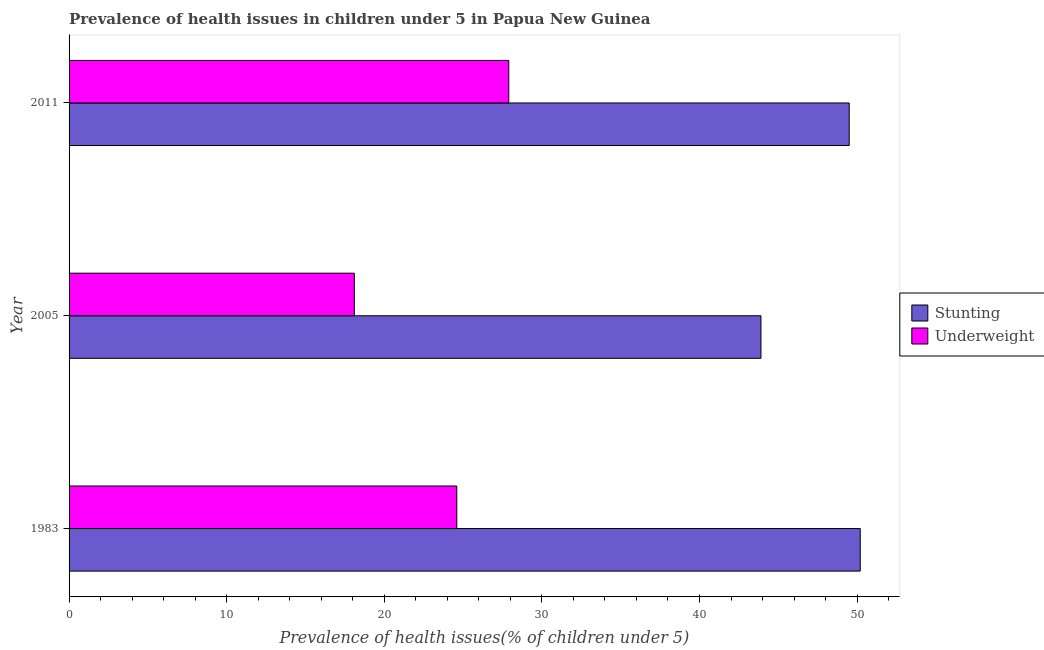Are the number of bars on each tick of the Y-axis equal?
Your answer should be very brief. Yes. How many bars are there on the 2nd tick from the bottom?
Keep it short and to the point. 2. What is the percentage of underweight children in 2011?
Your response must be concise. 27.9. Across all years, what is the maximum percentage of underweight children?
Offer a very short reply. 27.9. Across all years, what is the minimum percentage of underweight children?
Your response must be concise. 18.1. In which year was the percentage of stunted children maximum?
Provide a succinct answer. 1983. What is the total percentage of underweight children in the graph?
Ensure brevity in your answer.  70.6. What is the difference between the percentage of underweight children in 2011 and the percentage of stunted children in 1983?
Offer a very short reply. -22.3. What is the average percentage of stunted children per year?
Give a very brief answer. 47.87. In the year 2005, what is the difference between the percentage of stunted children and percentage of underweight children?
Offer a terse response. 25.8. In how many years, is the percentage of stunted children greater than 38 %?
Make the answer very short. 3. What is the ratio of the percentage of underweight children in 2005 to that in 2011?
Offer a terse response. 0.65. In how many years, is the percentage of stunted children greater than the average percentage of stunted children taken over all years?
Offer a very short reply. 2. Is the sum of the percentage of stunted children in 1983 and 2005 greater than the maximum percentage of underweight children across all years?
Offer a terse response. Yes. What does the 2nd bar from the top in 2011 represents?
Your answer should be compact. Stunting. What does the 2nd bar from the bottom in 2011 represents?
Offer a terse response. Underweight. Are all the bars in the graph horizontal?
Your answer should be compact. Yes. How are the legend labels stacked?
Offer a very short reply. Vertical. What is the title of the graph?
Ensure brevity in your answer.  Prevalence of health issues in children under 5 in Papua New Guinea. What is the label or title of the X-axis?
Your answer should be compact. Prevalence of health issues(% of children under 5). What is the Prevalence of health issues(% of children under 5) in Stunting in 1983?
Your answer should be very brief. 50.2. What is the Prevalence of health issues(% of children under 5) in Underweight in 1983?
Give a very brief answer. 24.6. What is the Prevalence of health issues(% of children under 5) in Stunting in 2005?
Offer a very short reply. 43.9. What is the Prevalence of health issues(% of children under 5) of Underweight in 2005?
Keep it short and to the point. 18.1. What is the Prevalence of health issues(% of children under 5) in Stunting in 2011?
Provide a succinct answer. 49.5. What is the Prevalence of health issues(% of children under 5) of Underweight in 2011?
Keep it short and to the point. 27.9. Across all years, what is the maximum Prevalence of health issues(% of children under 5) of Stunting?
Make the answer very short. 50.2. Across all years, what is the maximum Prevalence of health issues(% of children under 5) of Underweight?
Your answer should be very brief. 27.9. Across all years, what is the minimum Prevalence of health issues(% of children under 5) of Stunting?
Keep it short and to the point. 43.9. Across all years, what is the minimum Prevalence of health issues(% of children under 5) of Underweight?
Your response must be concise. 18.1. What is the total Prevalence of health issues(% of children under 5) of Stunting in the graph?
Your answer should be compact. 143.6. What is the total Prevalence of health issues(% of children under 5) of Underweight in the graph?
Provide a short and direct response. 70.6. What is the difference between the Prevalence of health issues(% of children under 5) of Underweight in 2005 and that in 2011?
Ensure brevity in your answer.  -9.8. What is the difference between the Prevalence of health issues(% of children under 5) in Stunting in 1983 and the Prevalence of health issues(% of children under 5) in Underweight in 2005?
Offer a very short reply. 32.1. What is the difference between the Prevalence of health issues(% of children under 5) of Stunting in 1983 and the Prevalence of health issues(% of children under 5) of Underweight in 2011?
Provide a short and direct response. 22.3. What is the difference between the Prevalence of health issues(% of children under 5) in Stunting in 2005 and the Prevalence of health issues(% of children under 5) in Underweight in 2011?
Provide a short and direct response. 16. What is the average Prevalence of health issues(% of children under 5) of Stunting per year?
Provide a succinct answer. 47.87. What is the average Prevalence of health issues(% of children under 5) in Underweight per year?
Your response must be concise. 23.53. In the year 1983, what is the difference between the Prevalence of health issues(% of children under 5) in Stunting and Prevalence of health issues(% of children under 5) in Underweight?
Offer a very short reply. 25.6. In the year 2005, what is the difference between the Prevalence of health issues(% of children under 5) in Stunting and Prevalence of health issues(% of children under 5) in Underweight?
Your answer should be compact. 25.8. In the year 2011, what is the difference between the Prevalence of health issues(% of children under 5) in Stunting and Prevalence of health issues(% of children under 5) in Underweight?
Offer a terse response. 21.6. What is the ratio of the Prevalence of health issues(% of children under 5) of Stunting in 1983 to that in 2005?
Make the answer very short. 1.14. What is the ratio of the Prevalence of health issues(% of children under 5) of Underweight in 1983 to that in 2005?
Make the answer very short. 1.36. What is the ratio of the Prevalence of health issues(% of children under 5) of Stunting in 1983 to that in 2011?
Make the answer very short. 1.01. What is the ratio of the Prevalence of health issues(% of children under 5) in Underweight in 1983 to that in 2011?
Ensure brevity in your answer.  0.88. What is the ratio of the Prevalence of health issues(% of children under 5) in Stunting in 2005 to that in 2011?
Your response must be concise. 0.89. What is the ratio of the Prevalence of health issues(% of children under 5) in Underweight in 2005 to that in 2011?
Your answer should be very brief. 0.65. What is the difference between the highest and the second highest Prevalence of health issues(% of children under 5) in Stunting?
Give a very brief answer. 0.7. 